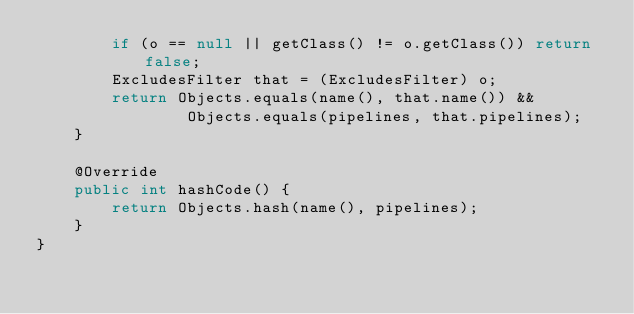Convert code to text. <code><loc_0><loc_0><loc_500><loc_500><_Java_>        if (o == null || getClass() != o.getClass()) return false;
        ExcludesFilter that = (ExcludesFilter) o;
        return Objects.equals(name(), that.name()) &&
                Objects.equals(pipelines, that.pipelines);
    }

    @Override
    public int hashCode() {
        return Objects.hash(name(), pipelines);
    }
}
</code> 